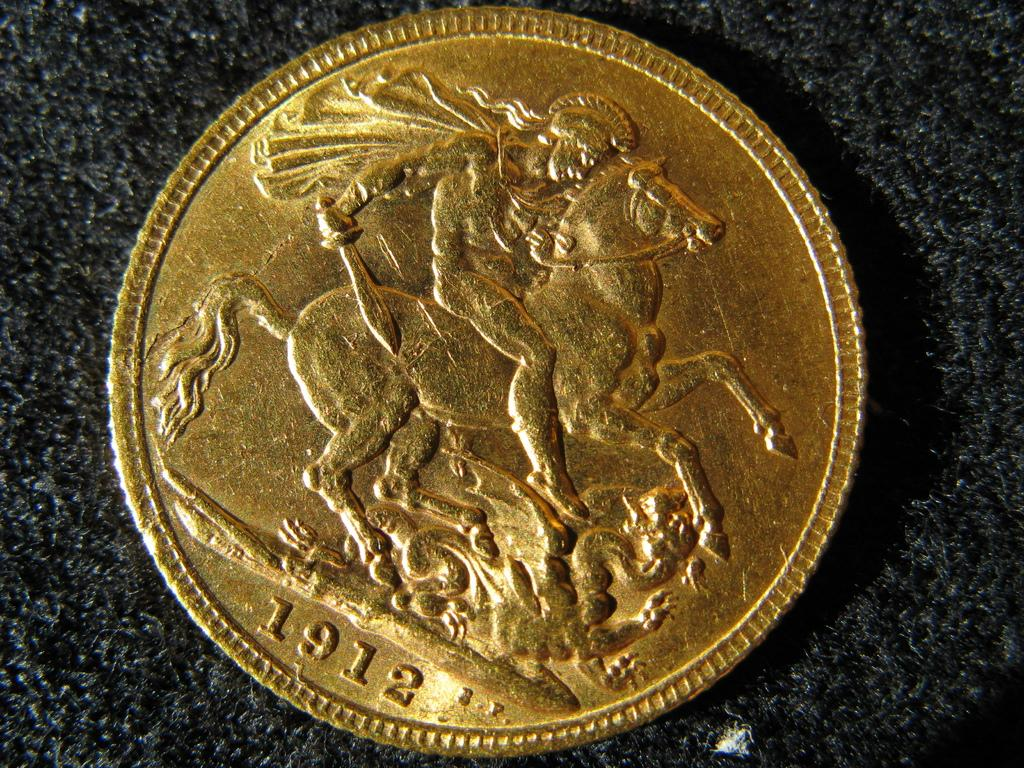<image>
Relay a brief, clear account of the picture shown. A gold coin with a man on a horse dated 1912. 